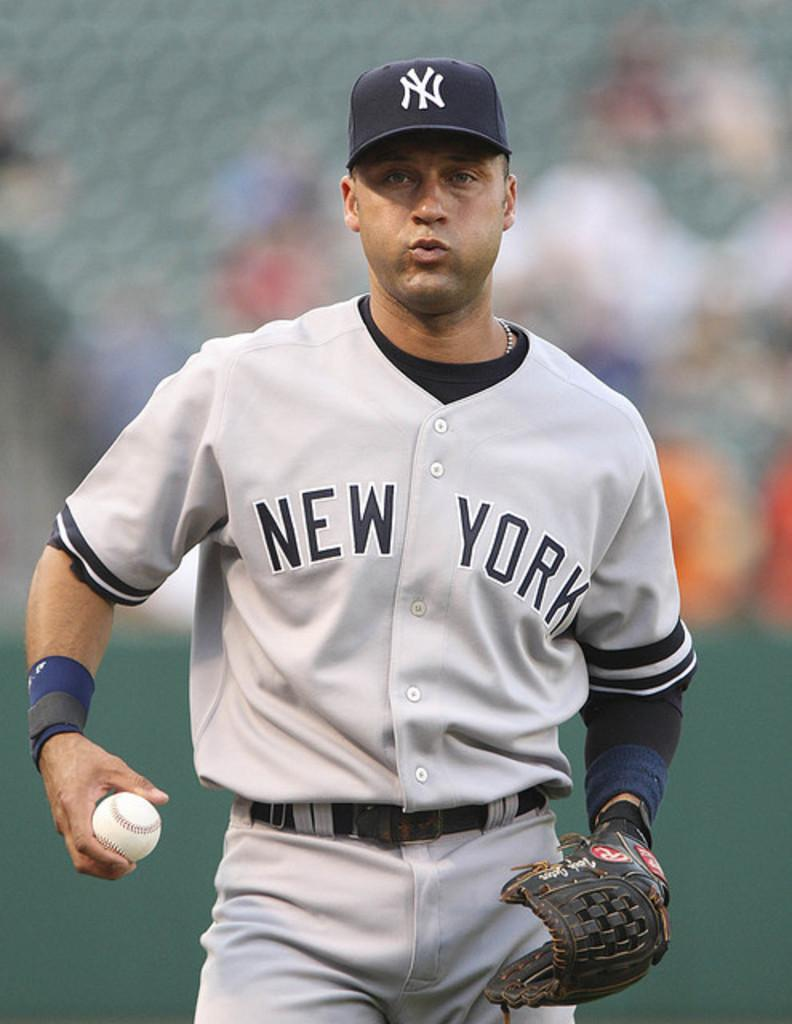<image>
Create a compact narrative representing the image presented. A player from the New York Yankees baseball team holding a baseball 